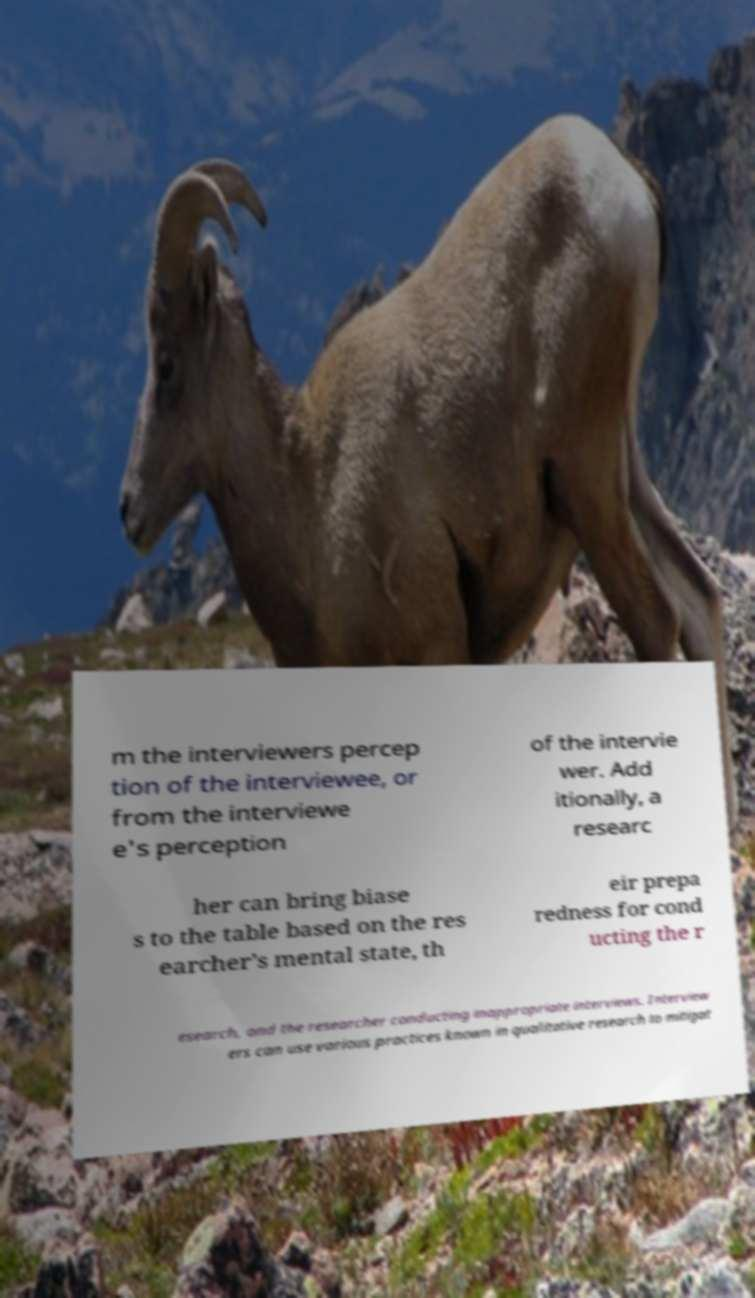Can you read and provide the text displayed in the image?This photo seems to have some interesting text. Can you extract and type it out for me? m the interviewers percep tion of the interviewee, or from the interviewe e's perception of the intervie wer. Add itionally, a researc her can bring biase s to the table based on the res earcher’s mental state, th eir prepa redness for cond ucting the r esearch, and the researcher conducting inappropriate interviews. Interview ers can use various practices known in qualitative research to mitigat 